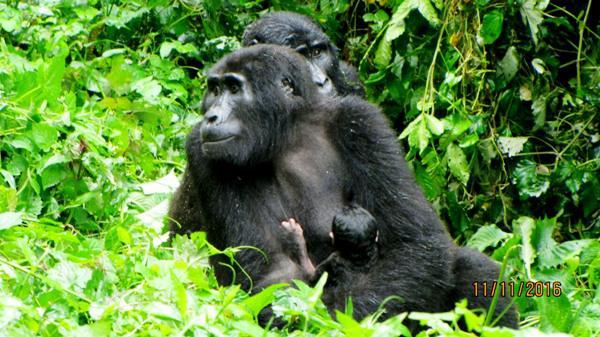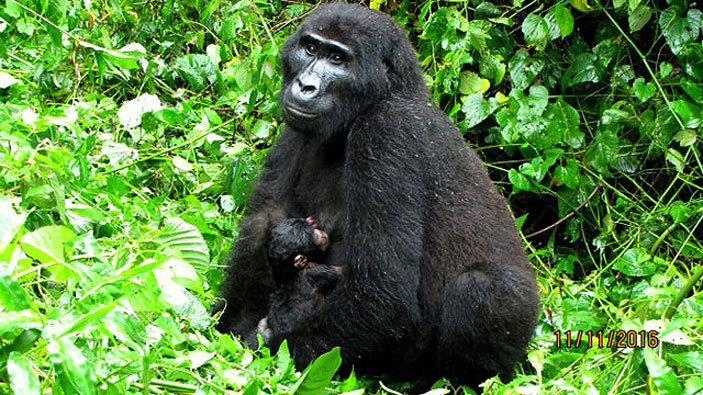The first image is the image on the left, the second image is the image on the right. Considering the images on both sides, is "Each image includes a baby gorilla close to an adult gorilla who is facing leftward." valid? Answer yes or no. Yes. The first image is the image on the left, the second image is the image on the right. Evaluate the accuracy of this statement regarding the images: "In at least one image there are two gorillas with the biggest facing forward left.". Is it true? Answer yes or no. Yes. 